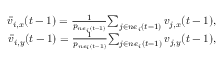Convert formula to latex. <formula><loc_0><loc_0><loc_500><loc_500>\begin{array} { r } { \bar { v } _ { i , x } ( t - 1 ) = \frac { 1 } { p _ { n e _ { i } ( t - 1 ) } } { \sum _ { j \in n e _ { i } ( t - 1 ) } v _ { j , x } ( t - 1 ) } , } \\ { \bar { v } _ { i , y } ( t - 1 ) = \frac { 1 } { p _ { n e _ { i } ( t - 1 ) } } { \sum _ { j \in n e _ { i } ( t - 1 ) } v _ { j , y } ( t - 1 ) } , } \end{array}</formula> 